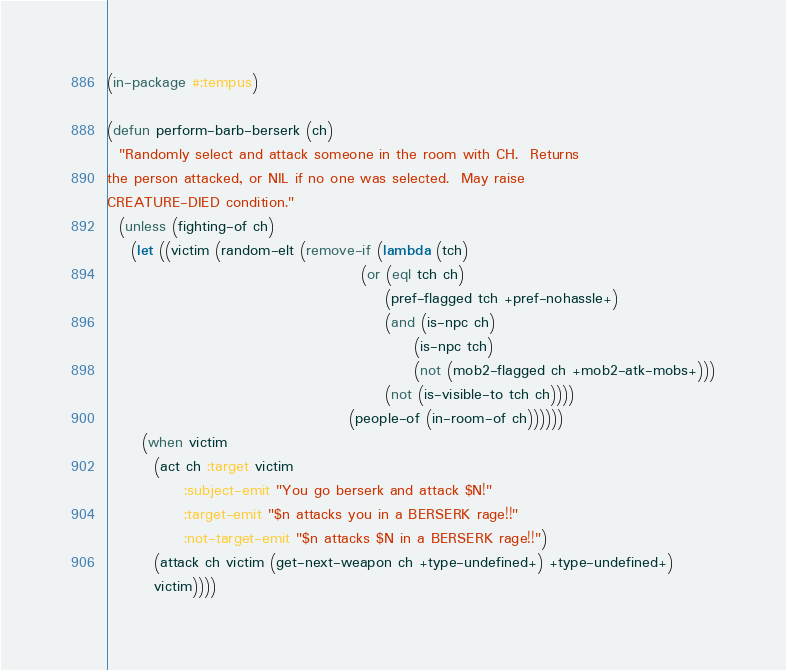Convert code to text. <code><loc_0><loc_0><loc_500><loc_500><_Lisp_>(in-package #:tempus)

(defun perform-barb-berserk (ch)
  "Randomly select and attack someone in the room with CH.  Returns
the person attacked, or NIL if no one was selected.  May raise
CREATURE-DIED condition."
  (unless (fighting-of ch)
    (let ((victim (random-elt (remove-if (lambda (tch)
                                           (or (eql tch ch)
                                               (pref-flagged tch +pref-nohassle+)
                                               (and (is-npc ch)
                                                    (is-npc tch)
                                                    (not (mob2-flagged ch +mob2-atk-mobs+)))
                                               (not (is-visible-to tch ch))))
                                         (people-of (in-room-of ch))))))
      (when victim
        (act ch :target victim
             :subject-emit "You go berserk and attack $N!"
             :target-emit "$n attacks you in a BERSERK rage!!"
             :not-target-emit "$n attacks $N in a BERSERK rage!!")
        (attack ch victim (get-next-weapon ch +type-undefined+) +type-undefined+)
        victim))))
</code> 